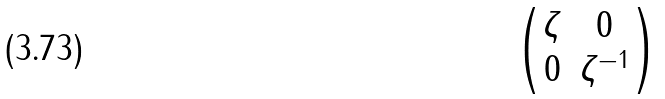<formula> <loc_0><loc_0><loc_500><loc_500>\begin{pmatrix} \zeta & 0 \\ 0 & \zeta ^ { - 1 } \\ \end{pmatrix}</formula> 